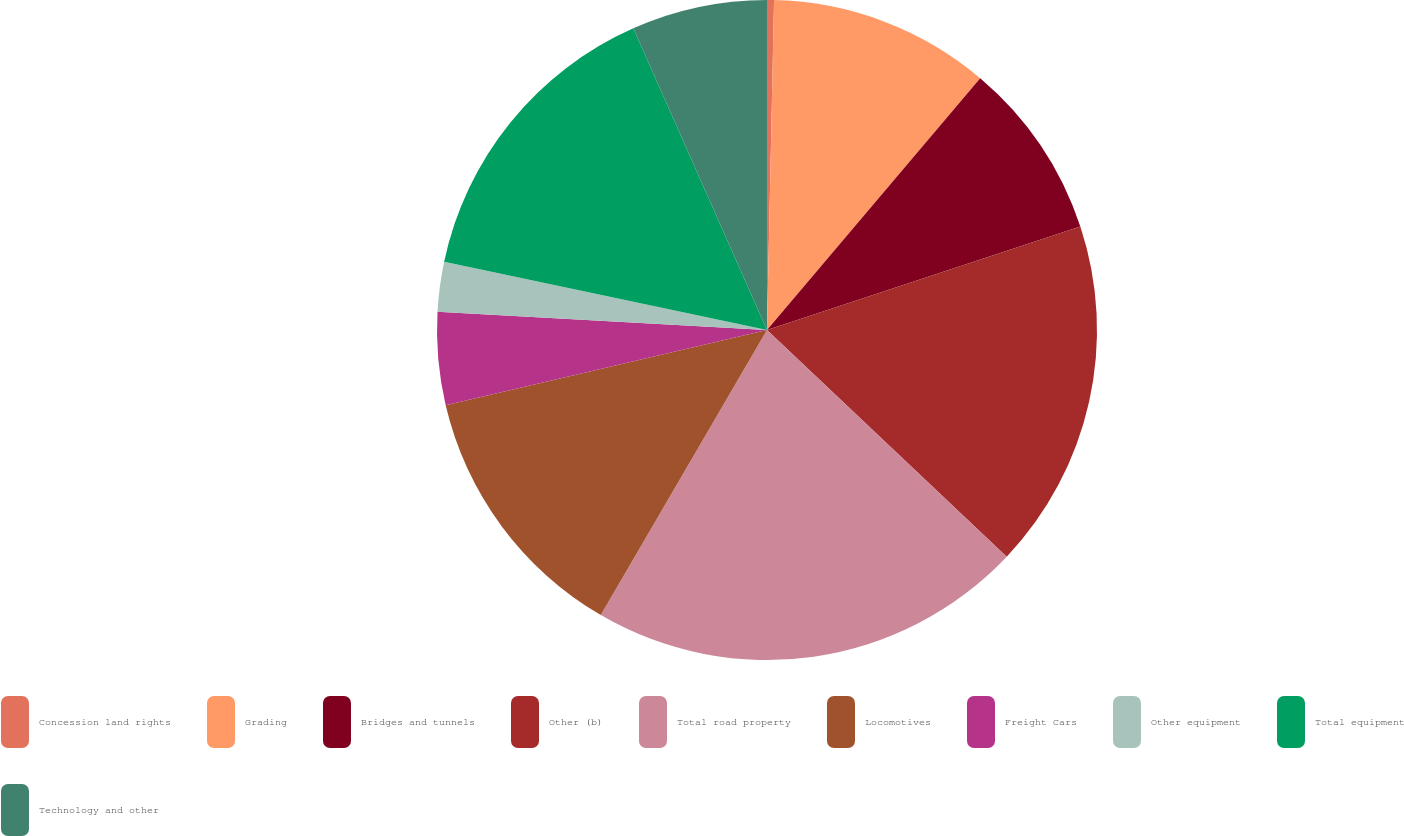Convert chart to OTSL. <chart><loc_0><loc_0><loc_500><loc_500><pie_chart><fcel>Concession land rights<fcel>Grading<fcel>Bridges and tunnels<fcel>Other (b)<fcel>Total road property<fcel>Locomotives<fcel>Freight Cars<fcel>Other equipment<fcel>Total equipment<fcel>Technology and other<nl><fcel>0.34%<fcel>10.84%<fcel>8.74%<fcel>17.14%<fcel>21.34%<fcel>12.94%<fcel>4.54%<fcel>2.44%<fcel>15.04%<fcel>6.64%<nl></chart> 